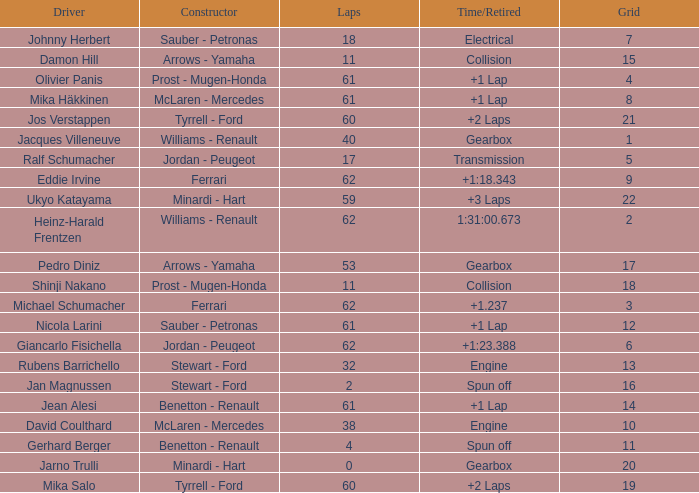What constructor has under 62 laps, a Time/Retired of gearbox, a Grid larger than 1, and pedro diniz driving? Arrows - Yamaha. 